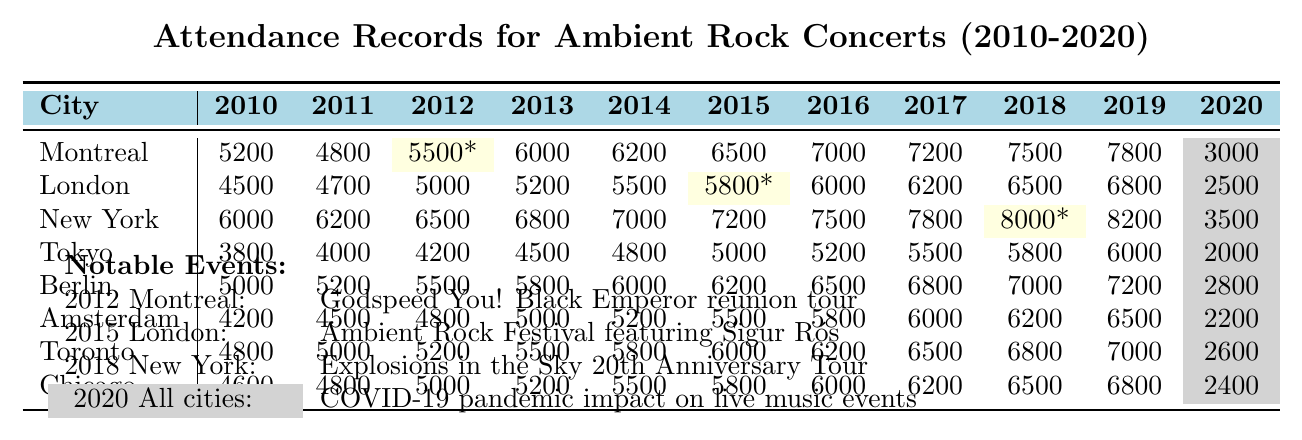What was the highest attendance recorded in New York? The highest attendance in New York can be found by looking at the row for New York in the attendance table. In 2019, the attendance reached 8200, which is the highest value for that city across the years.
Answer: 8200 Which city had the lowest attendance in 2020? By checking the attendance values for the year 2020, the lowest attendance is 2000, which is recorded for Tokyo.
Answer: Tokyo In which year did Montreal have a notable event, and what was it? The notable event for Montreal occurred in 2012, which is specified in the notable events section as the Godspeed You! Black Emperor reunion tour.
Answer: 2012, Godspeed You! Black Emperor reunion tour What is the difference in attendance for Montreal between 2012 and 2020? To find the difference, subtract the attendance in 2020 (3000) from the attendance in 2012 (5500). This gives a difference of 5500 - 3000 = 2500.
Answer: 2500 Which city had an increase in attendance every year from 2010 to 2019? Checking through the attendance values for each city from 2010 to 2019, New York shows consistent increases every year starting from 6000 in 2010 to 8200 in 2019, without a decline.
Answer: New York What was the average attendance in Berlin over the years 2010 to 2019? To calculate the average, sum the attendance values for Berlin from 2010 to 2019 (total = 5000 + 5200 + 5500 + 5800 + 6000 + 6200 + 6500 + 6800 + 7000 + 7200 =  56800), then divide by the number of years (10). The average is 56800 / 10 = 5680.
Answer: 5680 Did the attendance in Amsterdam decrease from 2015 to 2020? Checking the values, Amsterdam had an attendance of 5500 in 2015 and 2200 in 2020. Since 2200 is less than 5500, the attendance indeed decreased during this period.
Answer: Yes What city had the largest increase in attendance from 2010 to 2019? By examining the data, the increase for Montreal is from 5200 in 2010 to 7800 in 2019, an increase of 2600. When comparing other cities using similar calculations, New York also increases by 2200, but Montreal has a larger increase.
Answer: Montreal In 2015, what event took place in London? Referring to the notable events section, the event that took place in London in 2015 was the Ambient Rock Festival featuring Sigur Rós.
Answer: Ambient Rock Festival featuring Sigur Rós 